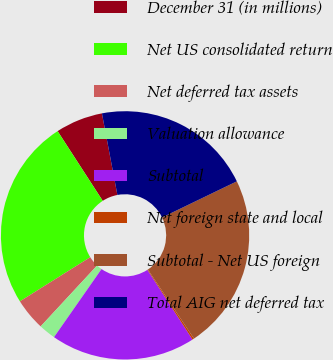Convert chart. <chart><loc_0><loc_0><loc_500><loc_500><pie_chart><fcel>December 31 (in millions)<fcel>Net US consolidated return<fcel>Net deferred tax assets<fcel>Valuation allowance<fcel>Subtotal<fcel>Net foreign state and local<fcel>Subtotal - Net US foreign<fcel>Total AIG net deferred tax<nl><fcel>6.16%<fcel>24.78%<fcel>4.18%<fcel>2.2%<fcel>18.84%<fcel>0.22%<fcel>22.8%<fcel>20.82%<nl></chart> 